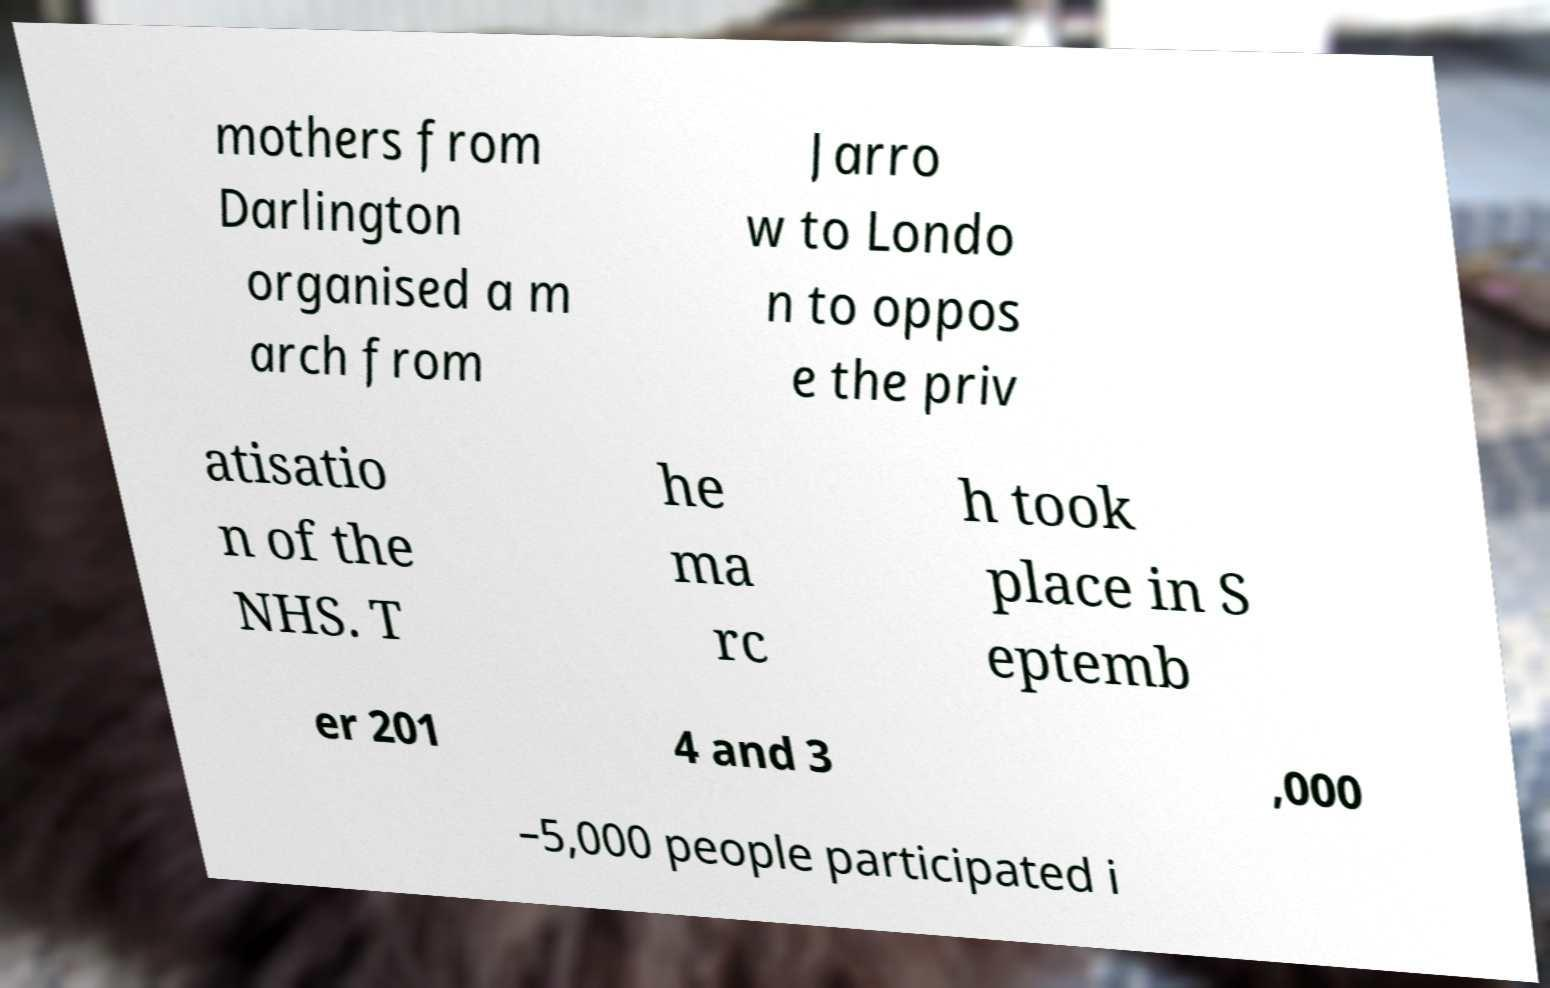Please identify and transcribe the text found in this image. mothers from Darlington organised a m arch from Jarro w to Londo n to oppos e the priv atisatio n of the NHS. T he ma rc h took place in S eptemb er 201 4 and 3 ,000 –5,000 people participated i 